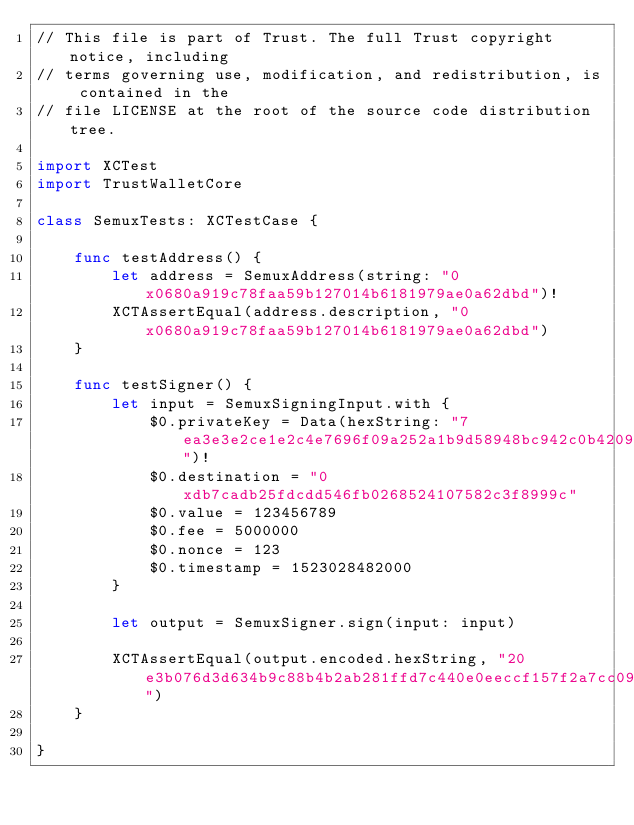<code> <loc_0><loc_0><loc_500><loc_500><_Swift_>// This file is part of Trust. The full Trust copyright notice, including
// terms governing use, modification, and redistribution, is contained in the
// file LICENSE at the root of the source code distribution tree.

import XCTest
import TrustWalletCore

class SemuxTests: XCTestCase {

    func testAddress() {
        let address = SemuxAddress(string: "0x0680a919c78faa59b127014b6181979ae0a62dbd")!
        XCTAssertEqual(address.description, "0x0680a919c78faa59b127014b6181979ae0a62dbd")
    }
    
    func testSigner() {
        let input = SemuxSigningInput.with {
            $0.privateKey = Data(hexString: "7ea3e3e2ce1e2c4e7696f09a252a1b9d58948bc942c0b42092080a896c43649f")!
            $0.destination = "0xdb7cadb25fdcdd546fb0268524107582c3f8999c"
            $0.value = 123456789
            $0.fee = 5000000
            $0.nonce = 123
            $0.timestamp = 1523028482000
        }

        let output = SemuxSigner.sign(input: input)

        XCTAssertEqual(output.encoded.hexString, "20e3b076d3d634b9c88b4b2ab281ffd7c440e0eeccf157f2a7cc09c3b7885958c738000114db7cadb25fdcdd546fb0268524107582c3f8999c00000000075bcd1500000000004c4b40000000000000007b000001629b9257d0006064f22068b0e9d103aaae81c099d1d59a44c7ec022550ab8dcccd28104a2a79d27c9dc9a277da765bd5bde2667af78a67a99aa33bf6e352e36546d0285526210e057f987e38f88037e8019cbb774dda106fc051fc4a6320a00294fe1866d08442")
    }
    
}
</code> 